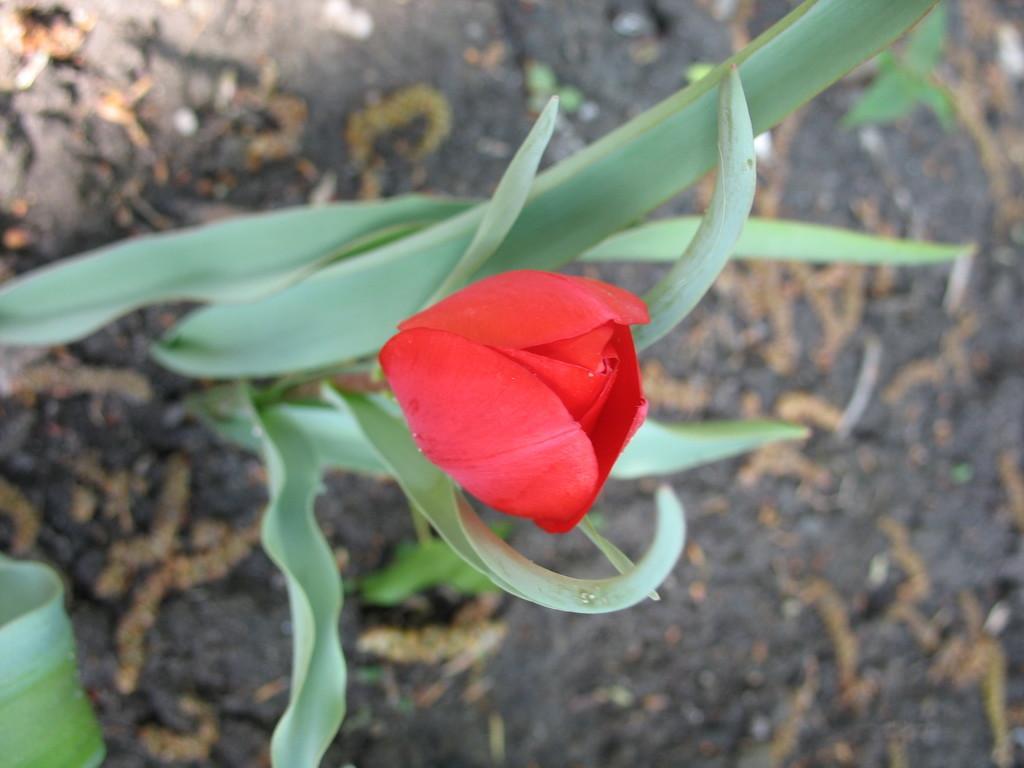Could you give a brief overview of what you see in this image? In this image, we can see a flower with plant. At the bottom, we can see a leaf. Background there is a ground. 